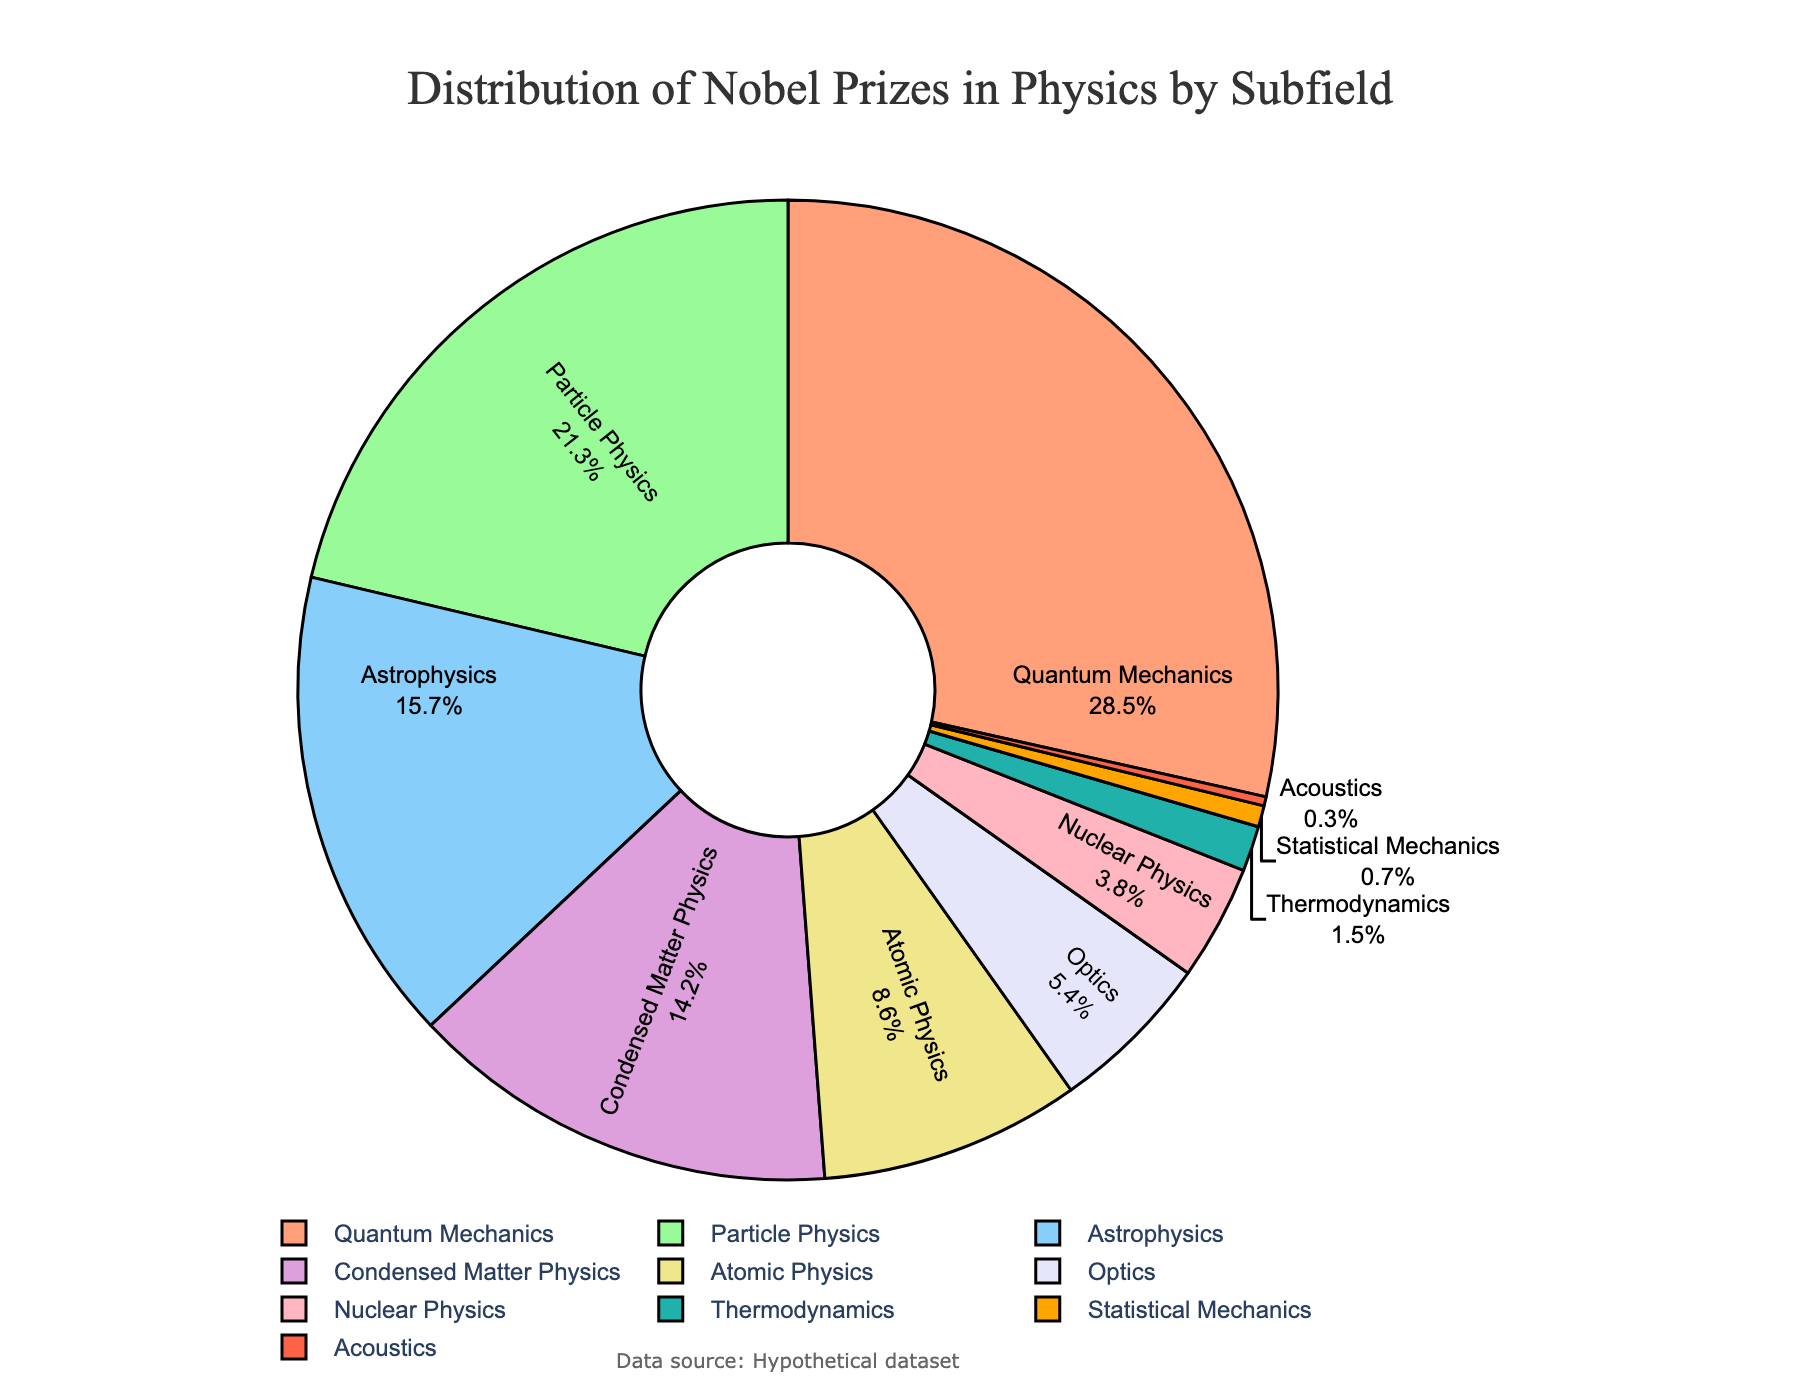Which subfield has the highest percentage of Nobel Prizes in Physics? By observing the pie chart, the largest segment is labeled "Quantum Mechanics" with a percentage of 28.5%. Therefore, Quantum Mechanics has the highest percentage of Nobel Prizes in Physics.
Answer: Quantum Mechanics Which subfield has the least representation in terms of Nobel Prizes in Physics? The smallest segment in the pie chart is labeled "Acoustics" with a percentage of 0.3%. Hence, Acoustics has the least representation.
Answer: Acoustics What is the combined percentage of Nobel Prizes in Physics for Quantum Mechanics and Particle Physics? Adding the percentages of Quantum Mechanics (28.5%) and Particle Physics (21.3%) gives a total of 49.8%.
Answer: 49.8% How much more is the percentage of Nobel Prizes in Quantum Mechanics than in Astrophysics? Subtract the percentage of Astrophysics (15.7%) from that of Quantum Mechanics (28.5%) to get the difference: 28.5% - 15.7% = 12.8%.
Answer: 12.8% Which subfield has a higher representation: Atomic Physics or Optics? By comparing the segments, Atomic Physics has 8.6% whereas Optics has 5.4%, so Atomic Physics has higher representation.
Answer: Atomic Physics Are the combined percentages of Optics and Nuclear Physics greater than that of Condensed Matter Physics? Adding the percentages of Optics (5.4%) and Nuclear Physics (3.8%) gives 9.2%, which is less than the 14.2% for Condensed Matter Physics.
Answer: No What is the total percentage of the subfields that have less than 10% representation each? Adding the percentages of Atomic Physics (8.6%), Optics (5.4%), Nuclear Physics (3.8%), Thermodynamics (1.5%), Statistical Mechanics (0.7%), and Acoustics (0.3%) gives a total of 20.3%.
Answer: 20.3% Which colors represent the subfields of Particle Physics and Condensed Matter Physics? Particle Physics is represented by the second color, which is green (#98FB98), and Condensed Matter Physics is the fourth color, which is purple (#DDA0DD).
Answer: Green and Purple Is Astrophysics represented by a larger segment than Condensed Matter Physics? The percentage for Astrophysics is 15.7% and for Condensed Matter Physics is 14.2%. Since 15.7% is greater than 14.2%, Astrophysics is represented by a larger segment.
Answer: Yes What is the combined percentage of subfields other than Quantum Mechanics and Particle Physics? Adding the percentages of Astrophysics (15.7%), Condensed Matter Physics (14.2%), Atomic Physics (8.6%), Optics (5.4%), Nuclear Physics (3.8%), Thermodynamics (1.5%), Statistical Mechanics (0.7%), and Acoustics (0.3%) gives 50.2%.
Answer: 50.2% 